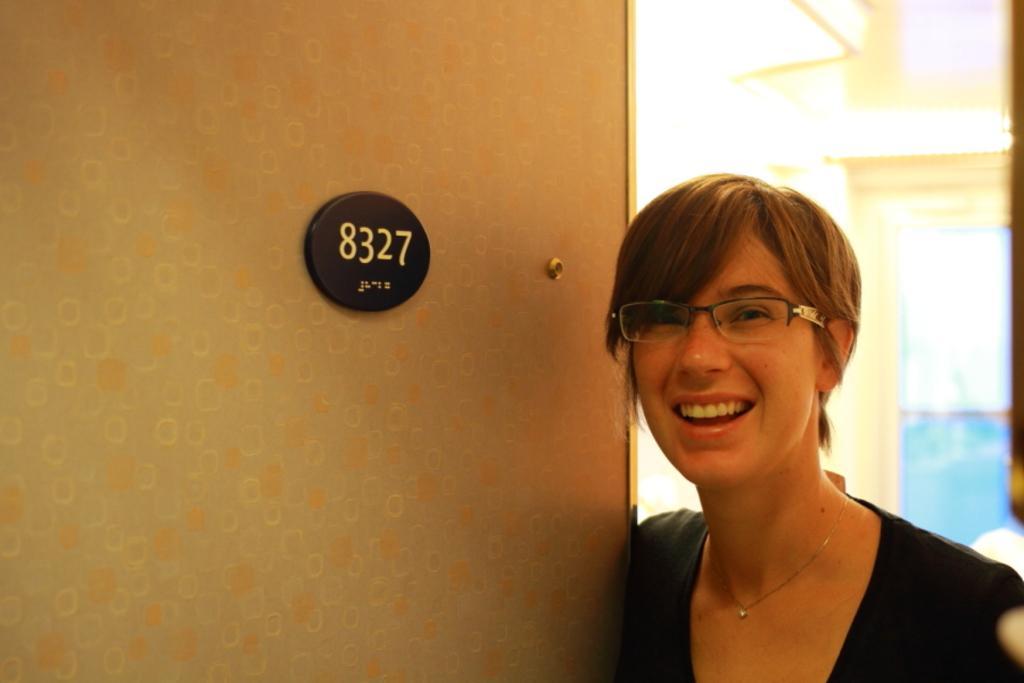Describe this image in one or two sentences. In this picture we can see a woman smiling. There is a number board. 